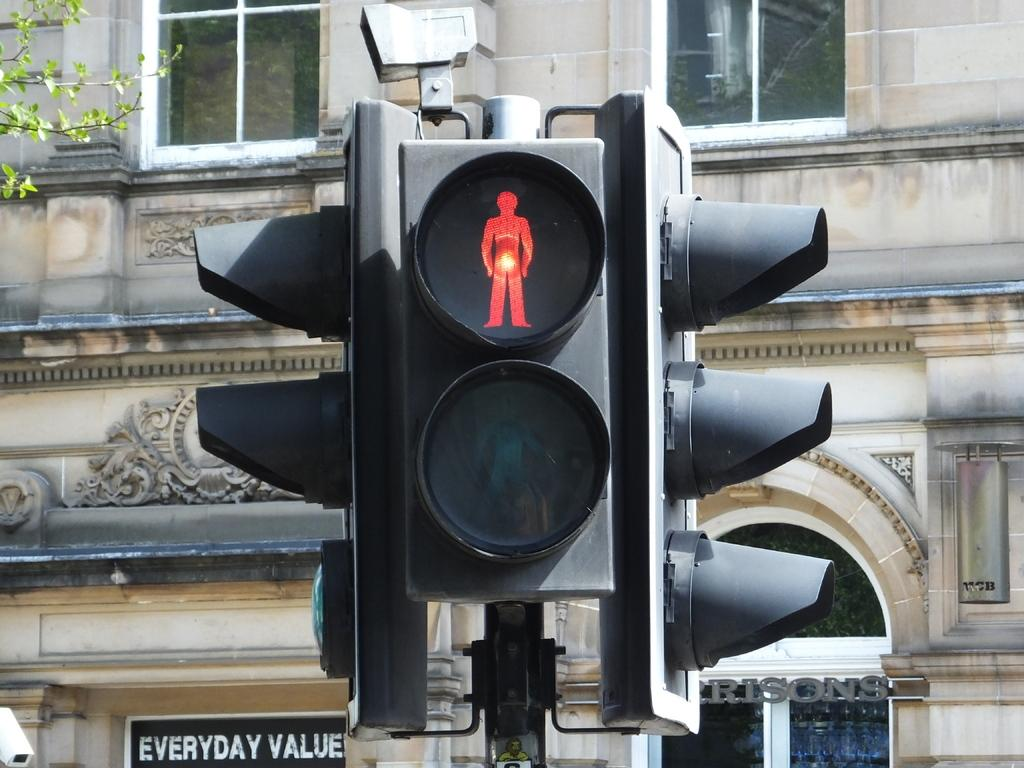<image>
Create a compact narrative representing the image presented. A stoplight with a sign next to it saying Everyday Value 